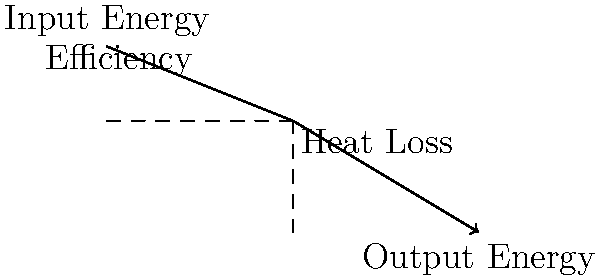In the context of discourse analysis, how might the concept of energy transfer in a simple machine, as depicted in the diagram, serve as a metaphor for the flow and potential loss of information in human argumentation? Discuss the parallels between energy efficiency in machines and the effectiveness of argument structures. To analyze this question from a cognitive science and discourse analysis perspective, we can break it down into several steps:

1. Energy Transfer Analogy:
   - Input Energy: This represents the initial argument or information presented.
   - Output Energy: This symbolizes the conveyed message or persuasive impact on the audience.
   - The downward slope indicates a gradual loss of energy, which in argumentation could represent the loss of impact or clarity.

2. Efficiency in Argumentation:
   - Just as machines have an efficiency rating, arguments can be evaluated for their effectiveness in conveying information.
   - The area between the input and output lines represents lost energy, which in argumentation could be:
     a) Misunderstood points
     b) Irrelevant information
     c) Logical fallacies
     d) Cognitive biases

3. Heat Loss Parallel:
   - In machines, heat loss is unavoidable; similarly, in arguments, some information loss or misinterpretation is often inevitable.
   - The challenge in both cases is to minimize this loss.

4. Structure of Argument:
   - The smooth curve suggests that well-structured arguments, like well-designed machines, can minimize energy/information loss.
   - Abrupt changes or inconsistencies in argument structure could lead to greater losses, similar to inefficiencies in machines.

5. Measurability:
   - Just as energy transfer can be quantified, the effectiveness of arguments could potentially be measured through various discourse analysis techniques.

6. Optimization:
   - The goal in both cases is to maximize output (persuasive impact or work done) for a given input (initial argument or energy).

7. Audience Consideration:
   - Different audiences may require different "argument machines," just as different tasks require different types of simple machines.

This metaphor allows for a structured analysis of argumentation processes, potentially offering new insights into how to construct and evaluate effective arguments.
Answer: Energy transfer in machines parallels information flow in arguments; both aim to maximize efficiency by minimizing losses and optimizing structure for the intended output. 